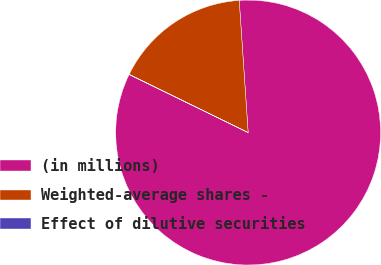Convert chart. <chart><loc_0><loc_0><loc_500><loc_500><pie_chart><fcel>(in millions)<fcel>Weighted-average shares -<fcel>Effect of dilutive securities<nl><fcel>83.29%<fcel>16.68%<fcel>0.03%<nl></chart> 